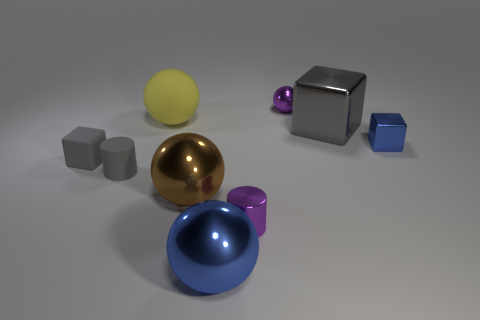Add 1 yellow spheres. How many objects exist? 10 Subtract all balls. How many objects are left? 5 Subtract 0 red cylinders. How many objects are left? 9 Subtract all brown metal spheres. Subtract all brown metallic spheres. How many objects are left? 7 Add 2 blocks. How many blocks are left? 5 Add 3 matte spheres. How many matte spheres exist? 4 